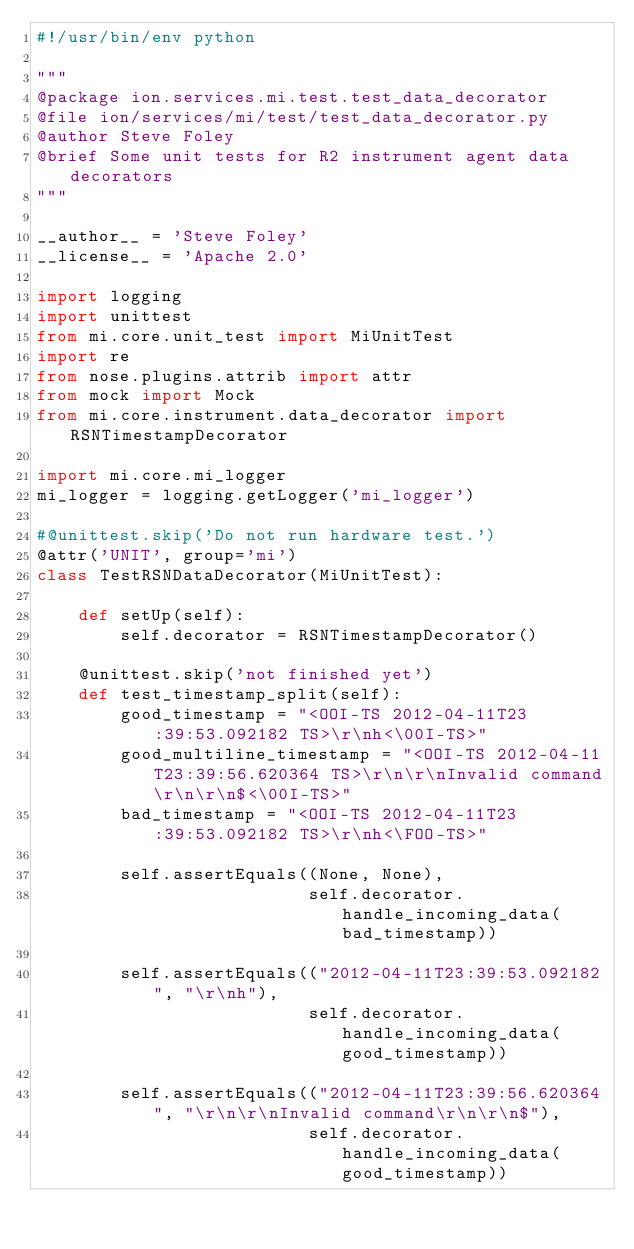Convert code to text. <code><loc_0><loc_0><loc_500><loc_500><_Python_>#!/usr/bin/env python

"""
@package ion.services.mi.test.test_data_decorator
@file ion/services/mi/test/test_data_decorator.py
@author Steve Foley
@brief Some unit tests for R2 instrument agent data decorators
"""

__author__ = 'Steve Foley'
__license__ = 'Apache 2.0'

import logging
import unittest
from mi.core.unit_test import MiUnitTest
import re
from nose.plugins.attrib import attr
from mock import Mock
from mi.core.instrument.data_decorator import RSNTimestampDecorator

import mi.core.mi_logger
mi_logger = logging.getLogger('mi_logger')

#@unittest.skip('Do not run hardware test.')
@attr('UNIT', group='mi')
class TestRSNDataDecorator(MiUnitTest):

    def setUp(self):
        self.decorator = RSNTimestampDecorator()
    
    @unittest.skip('not finished yet')
    def test_timestamp_split(self):
        good_timestamp = "<OOI-TS 2012-04-11T23:39:53.092182 TS>\r\nh<\00I-TS>"
        good_multiline_timestamp = "<OOI-TS 2012-04-11T23:39:56.620364 TS>\r\n\r\nInvalid command\r\n\r\n$<\00I-TS>"
        bad_timestamp = "<OOI-TS 2012-04-11T23:39:53.092182 TS>\r\nh<\FOO-TS>"
            
        self.assertEquals((None, None),
                          self.decorator.handle_incoming_data(bad_timestamp))
        
        self.assertEquals(("2012-04-11T23:39:53.092182", "\r\nh"),
                          self.decorator.handle_incoming_data(good_timestamp))
        
        self.assertEquals(("2012-04-11T23:39:56.620364", "\r\n\r\nInvalid command\r\n\r\n$"),
                          self.decorator.handle_incoming_data(good_timestamp))
</code> 